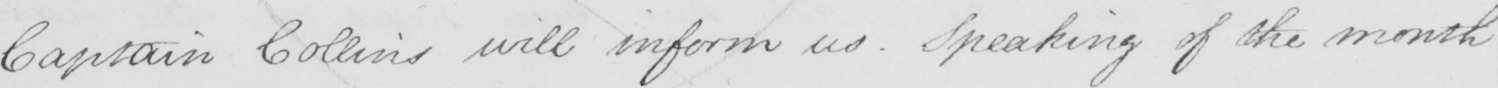Please transcribe the handwritten text in this image. Captain Collins will inform us . Speaking of the month 